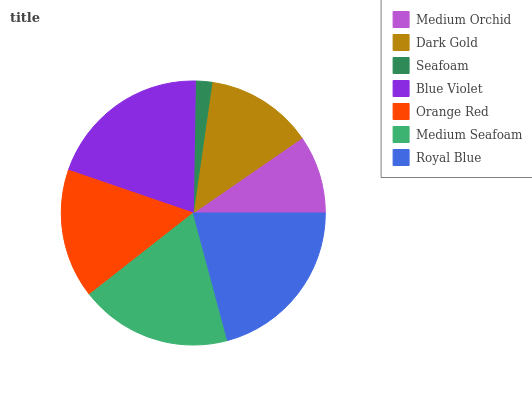Is Seafoam the minimum?
Answer yes or no. Yes. Is Royal Blue the maximum?
Answer yes or no. Yes. Is Dark Gold the minimum?
Answer yes or no. No. Is Dark Gold the maximum?
Answer yes or no. No. Is Dark Gold greater than Medium Orchid?
Answer yes or no. Yes. Is Medium Orchid less than Dark Gold?
Answer yes or no. Yes. Is Medium Orchid greater than Dark Gold?
Answer yes or no. No. Is Dark Gold less than Medium Orchid?
Answer yes or no. No. Is Orange Red the high median?
Answer yes or no. Yes. Is Orange Red the low median?
Answer yes or no. Yes. Is Seafoam the high median?
Answer yes or no. No. Is Medium Seafoam the low median?
Answer yes or no. No. 